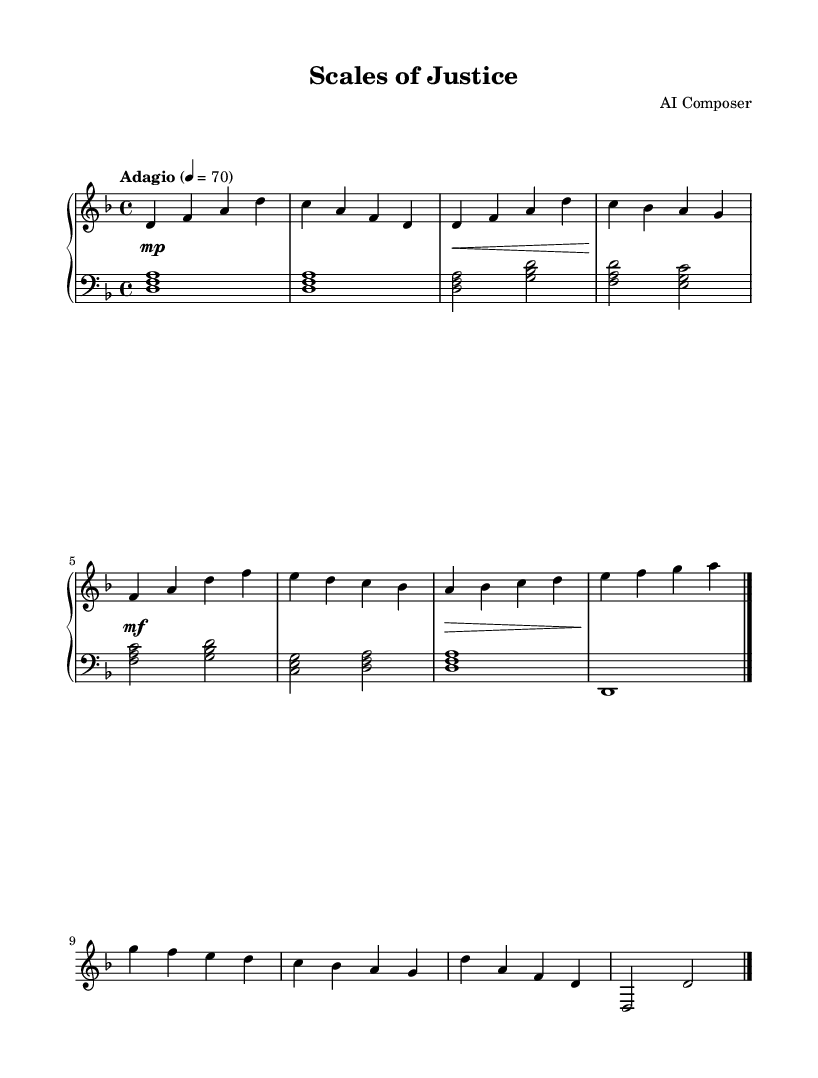What is the key signature of this music? The key signature is indicated by the presence of one flat (B♭), which is characteristic of the D minor scale.
Answer: D minor What is the time signature of this music? The time signature is found at the beginning of the sheet music, displaying a four over four notation, indicating a common time with four beats per measure.
Answer: 4/4 What is the tempo marking of this piece? The tempo marking in the sheet music is specified as "Adagio", meaning a slow tempo, typically around 66-76 beats per minute.
Answer: Adagio How many main themes are present in the piece? The sheet music contains two distinct themes, labeled as Theme A and Theme B, as seen in the structure of the piece.
Answer: Two Which section has the dynamics marked as "mf"? The dynamics marking "mf" (mezzo-forte) appears in the third section of the music, specifically under Theme A, indicating a moderately loud volume.
Answer: Theme A What is the final note of the coda? The final note of the coda is D, which is the tonic of the D minor key, providing closure to the musical piece.
Answer: D What type of accompaniment is used in the left hand? The left hand accompaniment in the sheet music consists of block chords, following a specific harmonic pattern that supports the right hand melody.
Answer: Block chords 